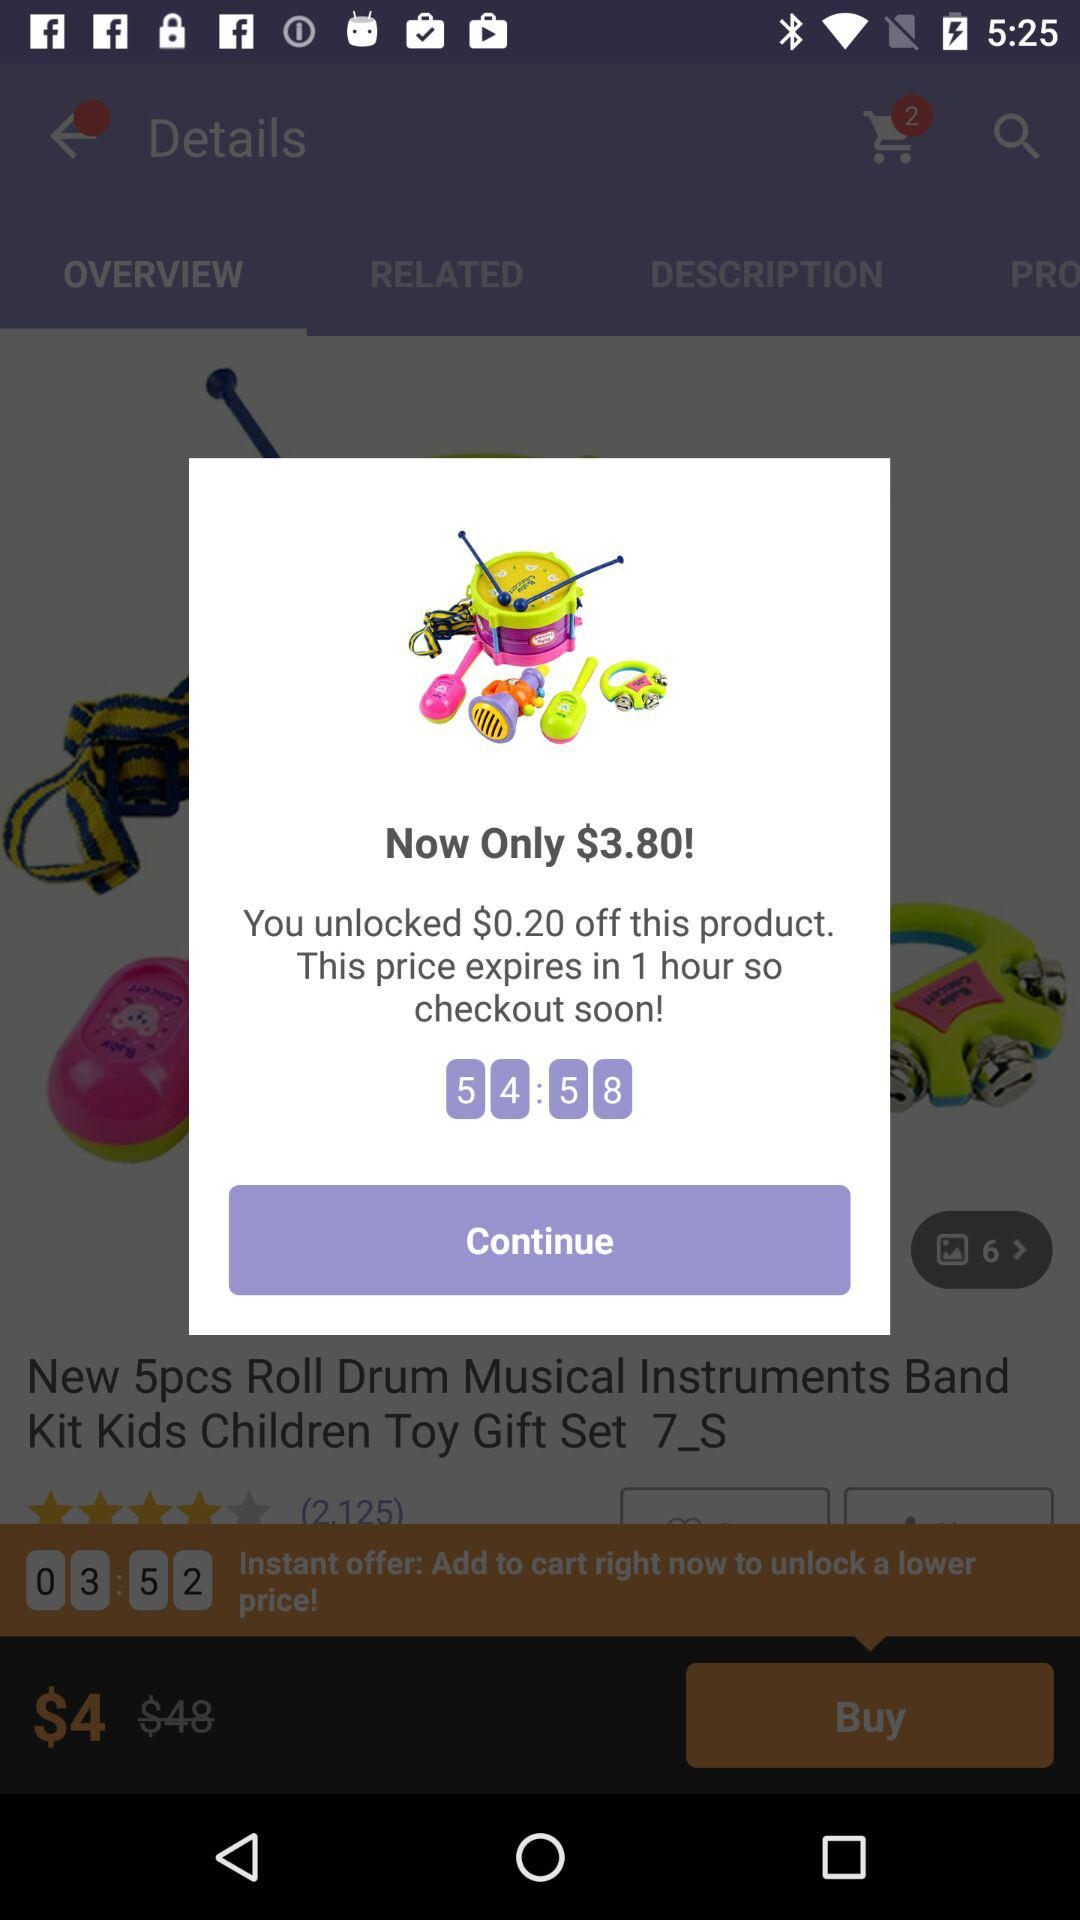What is the review?
When the provided information is insufficient, respond with <no answer>. <no answer> 